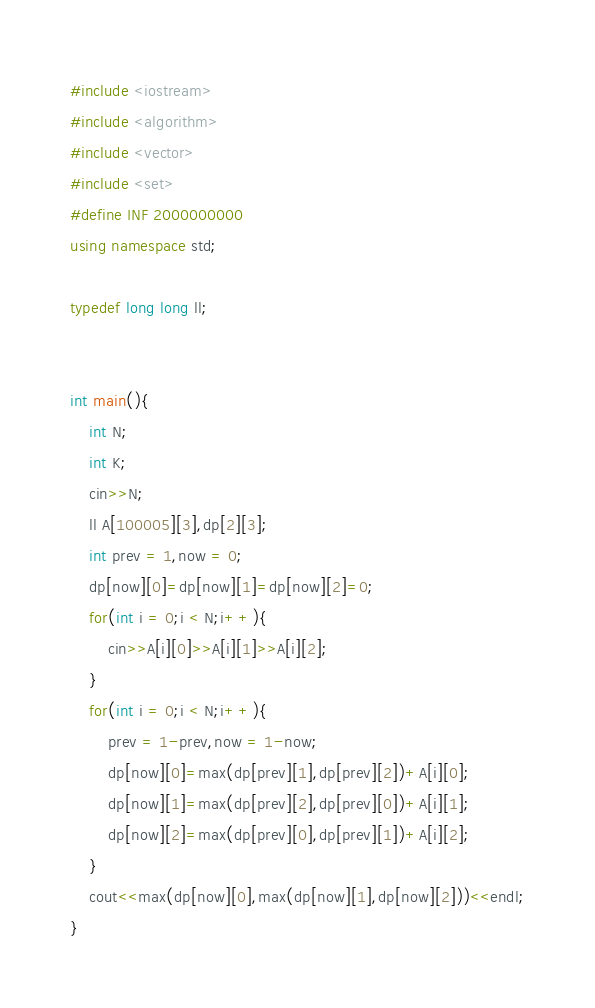<code> <loc_0><loc_0><loc_500><loc_500><_C++_>#include <iostream>
#include <algorithm>
#include <vector>
#include <set>
#define INF 2000000000
using namespace std;

typedef long long ll;


int main(){
    int N;
    int K;
    cin>>N;
    ll A[100005][3],dp[2][3];
    int prev = 1,now = 0;
    dp[now][0]=dp[now][1]=dp[now][2]=0;
    for(int i = 0;i < N;i++){
        cin>>A[i][0]>>A[i][1]>>A[i][2];
    }
    for(int i = 0;i < N;i++){
        prev = 1-prev,now = 1-now;
        dp[now][0]=max(dp[prev][1],dp[prev][2])+A[i][0];
        dp[now][1]=max(dp[prev][2],dp[prev][0])+A[i][1];
        dp[now][2]=max(dp[prev][0],dp[prev][1])+A[i][2];
    }
    cout<<max(dp[now][0],max(dp[now][1],dp[now][2]))<<endl;
}
</code> 